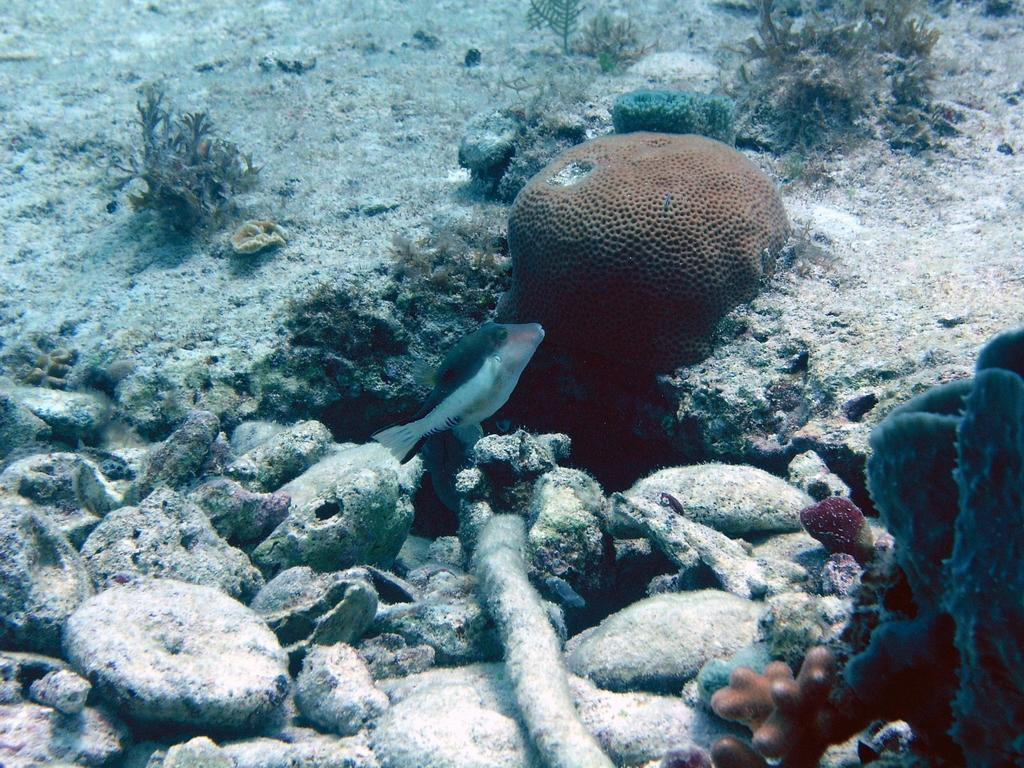Describe this image in one or two sentences. In this picture we can observe a fish swimming in the water. There are some stones on the land. We can observe some plants in the background. 